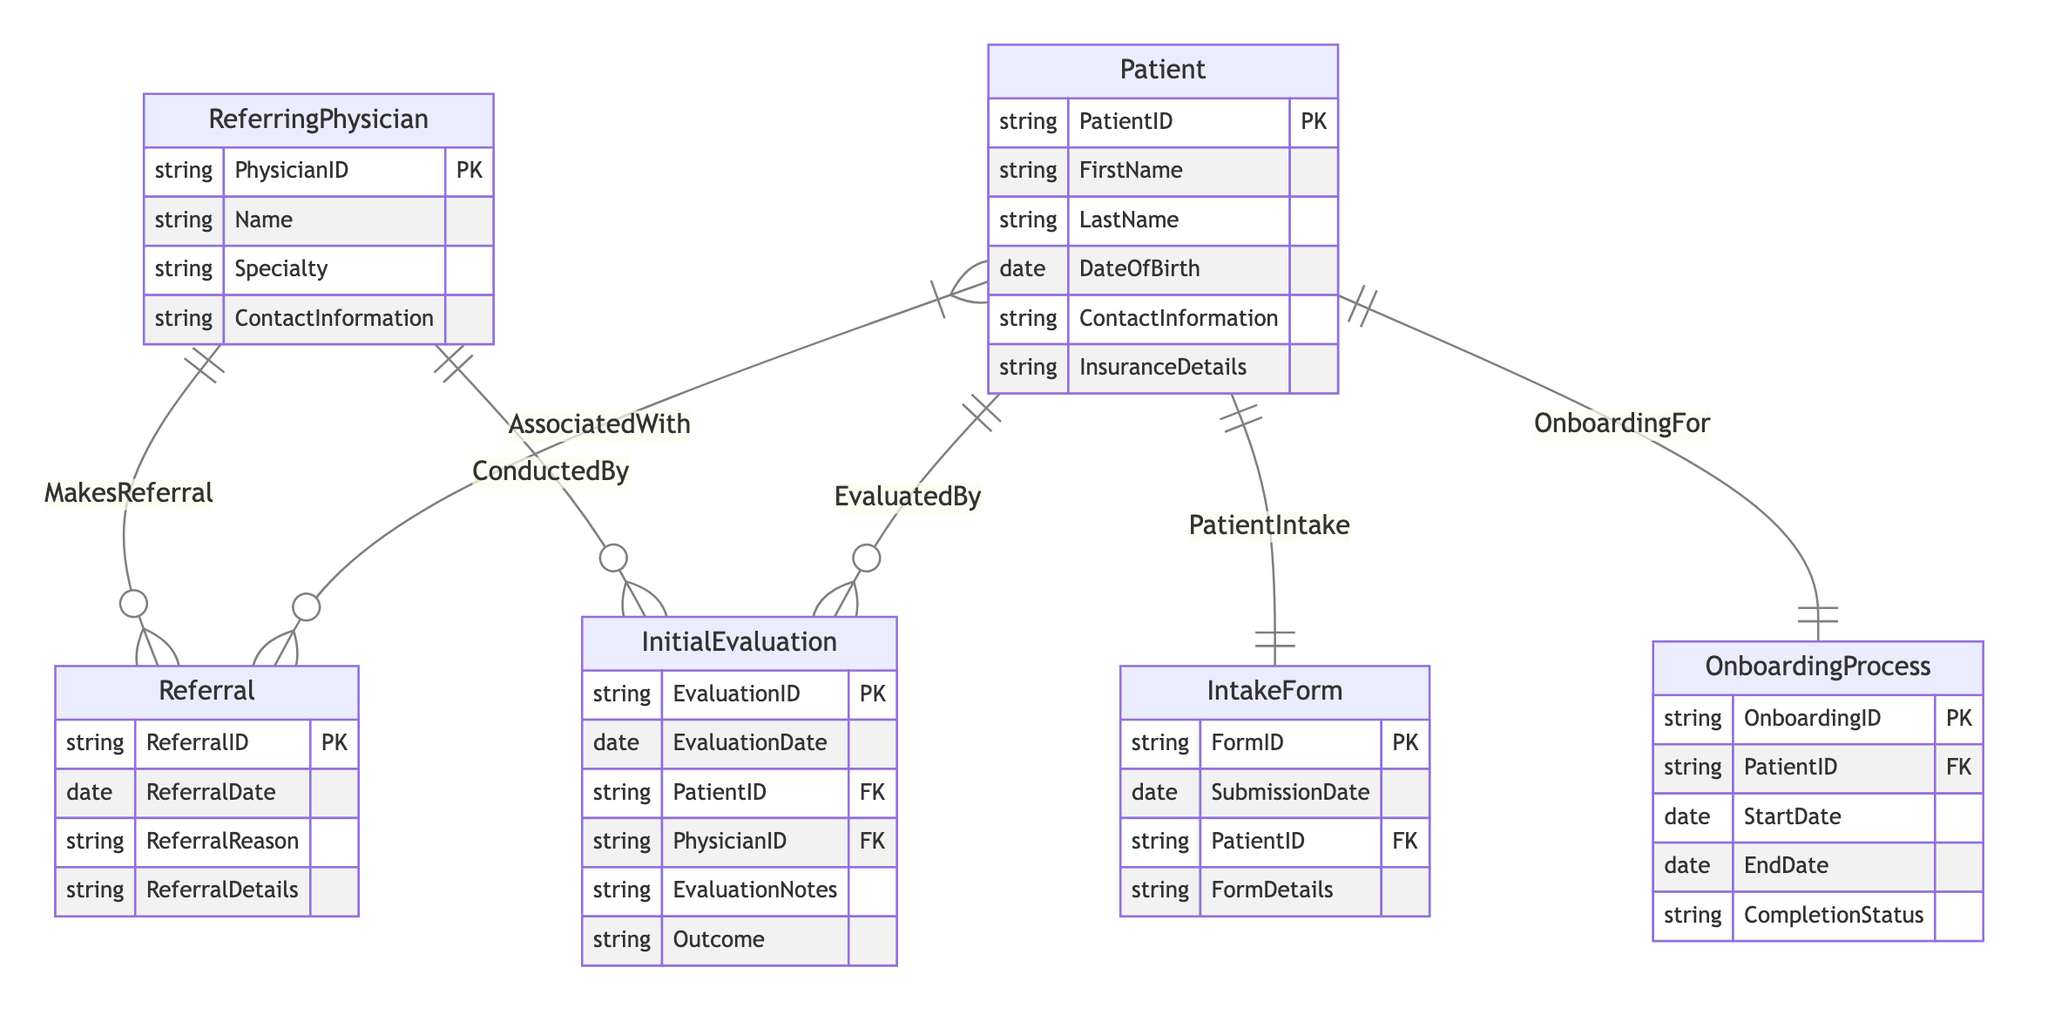What is the primary key of the Patient entity? The Patient entity has the attribute "PatientID" listed as its primary key (PK), which uniquely identifies each patient in the database.
Answer: PatientID How many entities are involved in this ER diagram? The diagram lists six distinct entities: ReferringPhysician, Patient, Referral, IntakeForm, InitialEvaluation, and OnboardingProcess, thus totaling six entities.
Answer: 6 Which entity is associated with the "MakesReferral" relationship? The "MakesReferral" relationship connects the ReferringPhysician entity with the Referral entity, indicating that a physician makes referrals.
Answer: ReferringPhysician and Referral How many relationships are defined in this diagram? There are five relationships present in the diagram: MakesReferral, PatientIntake, AssociatedWith, EvaluatedBy, ConductedBy, and OnboardingFor, leading to a total of five relationships.
Answer: 6 What is the relationship type between Patient and InitialEvaluation? The relationship type between Patient and InitialEvaluation is "one-to-many," indicating that one patient can have multiple initial evaluations.
Answer: one-to-many Which entity is mentioned in the "OnboardingFor" relationship? The "OnboardingFor" relationship specifically involves the OnboardingProcess entity, linking it directly with the Patient entity to indicate that onboarding is for a patient.
Answer: OnboardingProcess What information does the IntakeForm entity contain? The IntakeForm entity contains several attributes, including FormID, SubmissionDate, PatientID, and FormDetails, which pertain to the intake documents submitted by patients.
Answer: FormID, SubmissionDate, PatientID, FormDetails What type of relationship exists between ReferringPhysician and InitialEvaluation? The relationship between ReferringPhysician and InitialEvaluation is a "one-to-many" relationship, meaning a single referring physician can conduct many initial evaluations.
Answer: one-to-many Which entity requires a completion status related to patient onboarding? The OnboardingProcess entity contains the attribute "CompletionStatus," which indicates whether the onboarding process for a patient has been completed.
Answer: CompletionStatus 